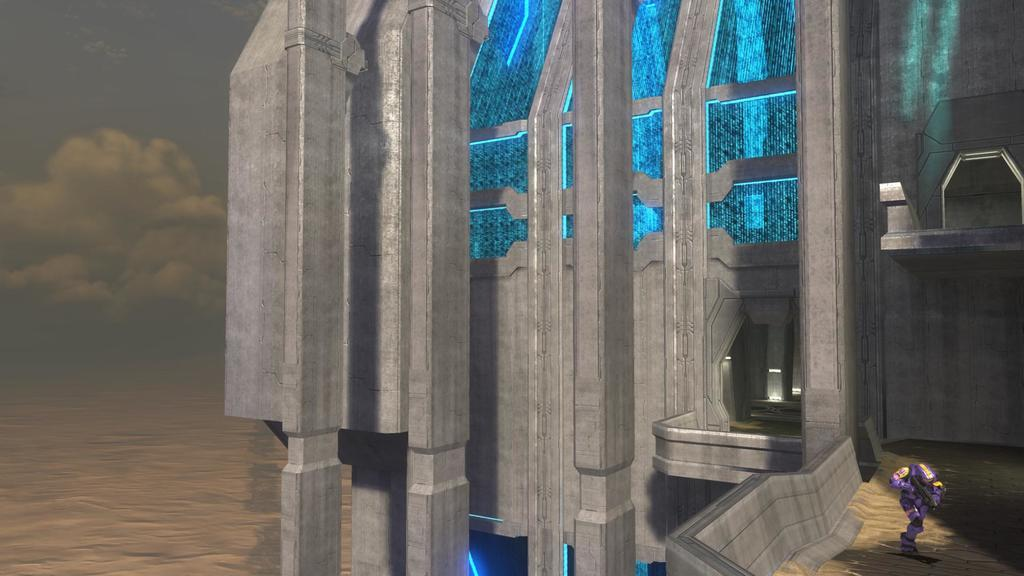What type of media is the image? The image is an animation. What structure can be seen in the image? There is a building in the image. What is located on the right side of the image? There is a robot on the right side of the image. What is present on the left side of the image? There is water on the left side of the image. What can be seen in the background of the image? The sky is visible in the background of the image. What type of shoes is the robot wearing in the image? There is no indication of the robot wearing shoes in the image. What is the current status of the robot in the image? The image is a still frame from an animation, so there is no current status of the robot. 